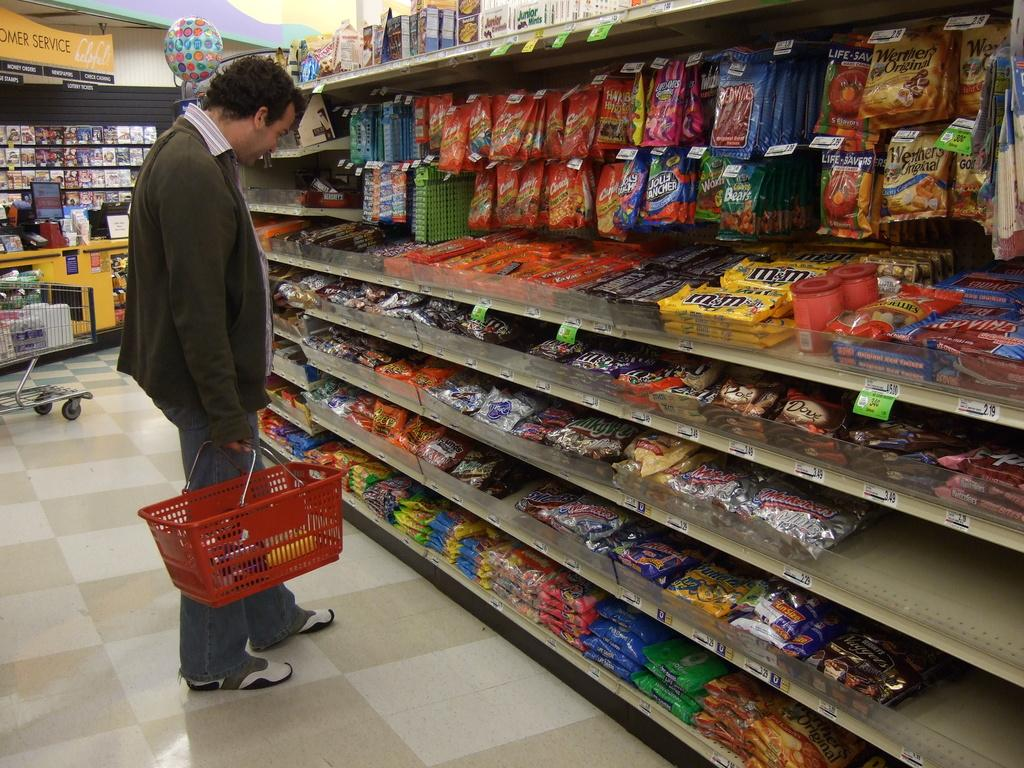<image>
Provide a brief description of the given image. A man wearing a brown sweater standing in a grocery store looking at a rack of m&m candies among other brands. 